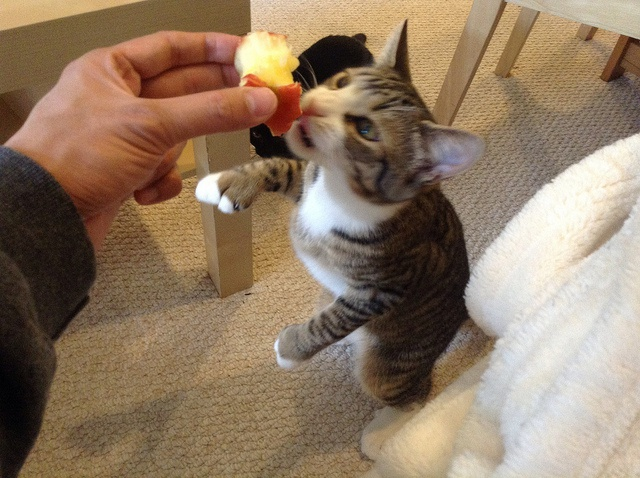Describe the objects in this image and their specific colors. I can see cat in tan, black, gray, and darkgray tones, people in tan, black, maroon, brown, and salmon tones, dining table in tan, olive, and gray tones, and apple in tan, khaki, gold, maroon, and lightyellow tones in this image. 